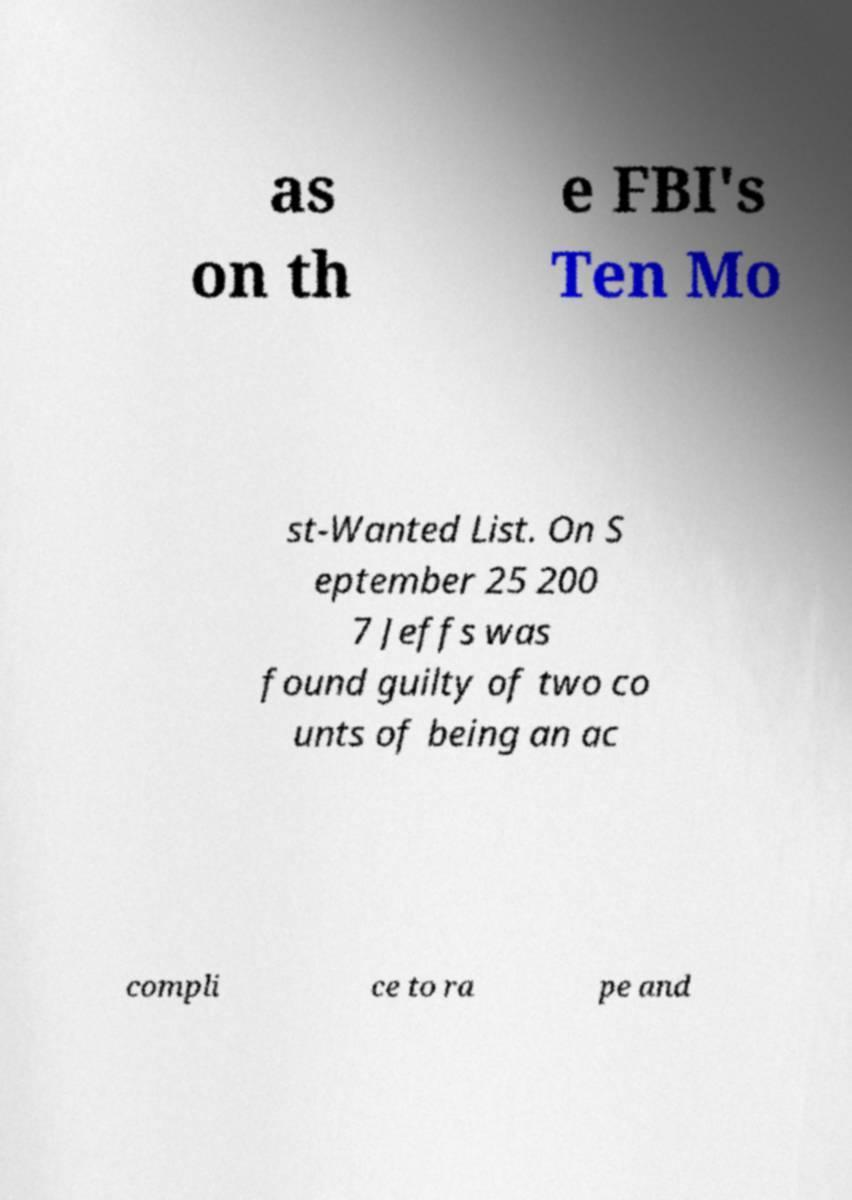Could you assist in decoding the text presented in this image and type it out clearly? as on th e FBI's Ten Mo st-Wanted List. On S eptember 25 200 7 Jeffs was found guilty of two co unts of being an ac compli ce to ra pe and 